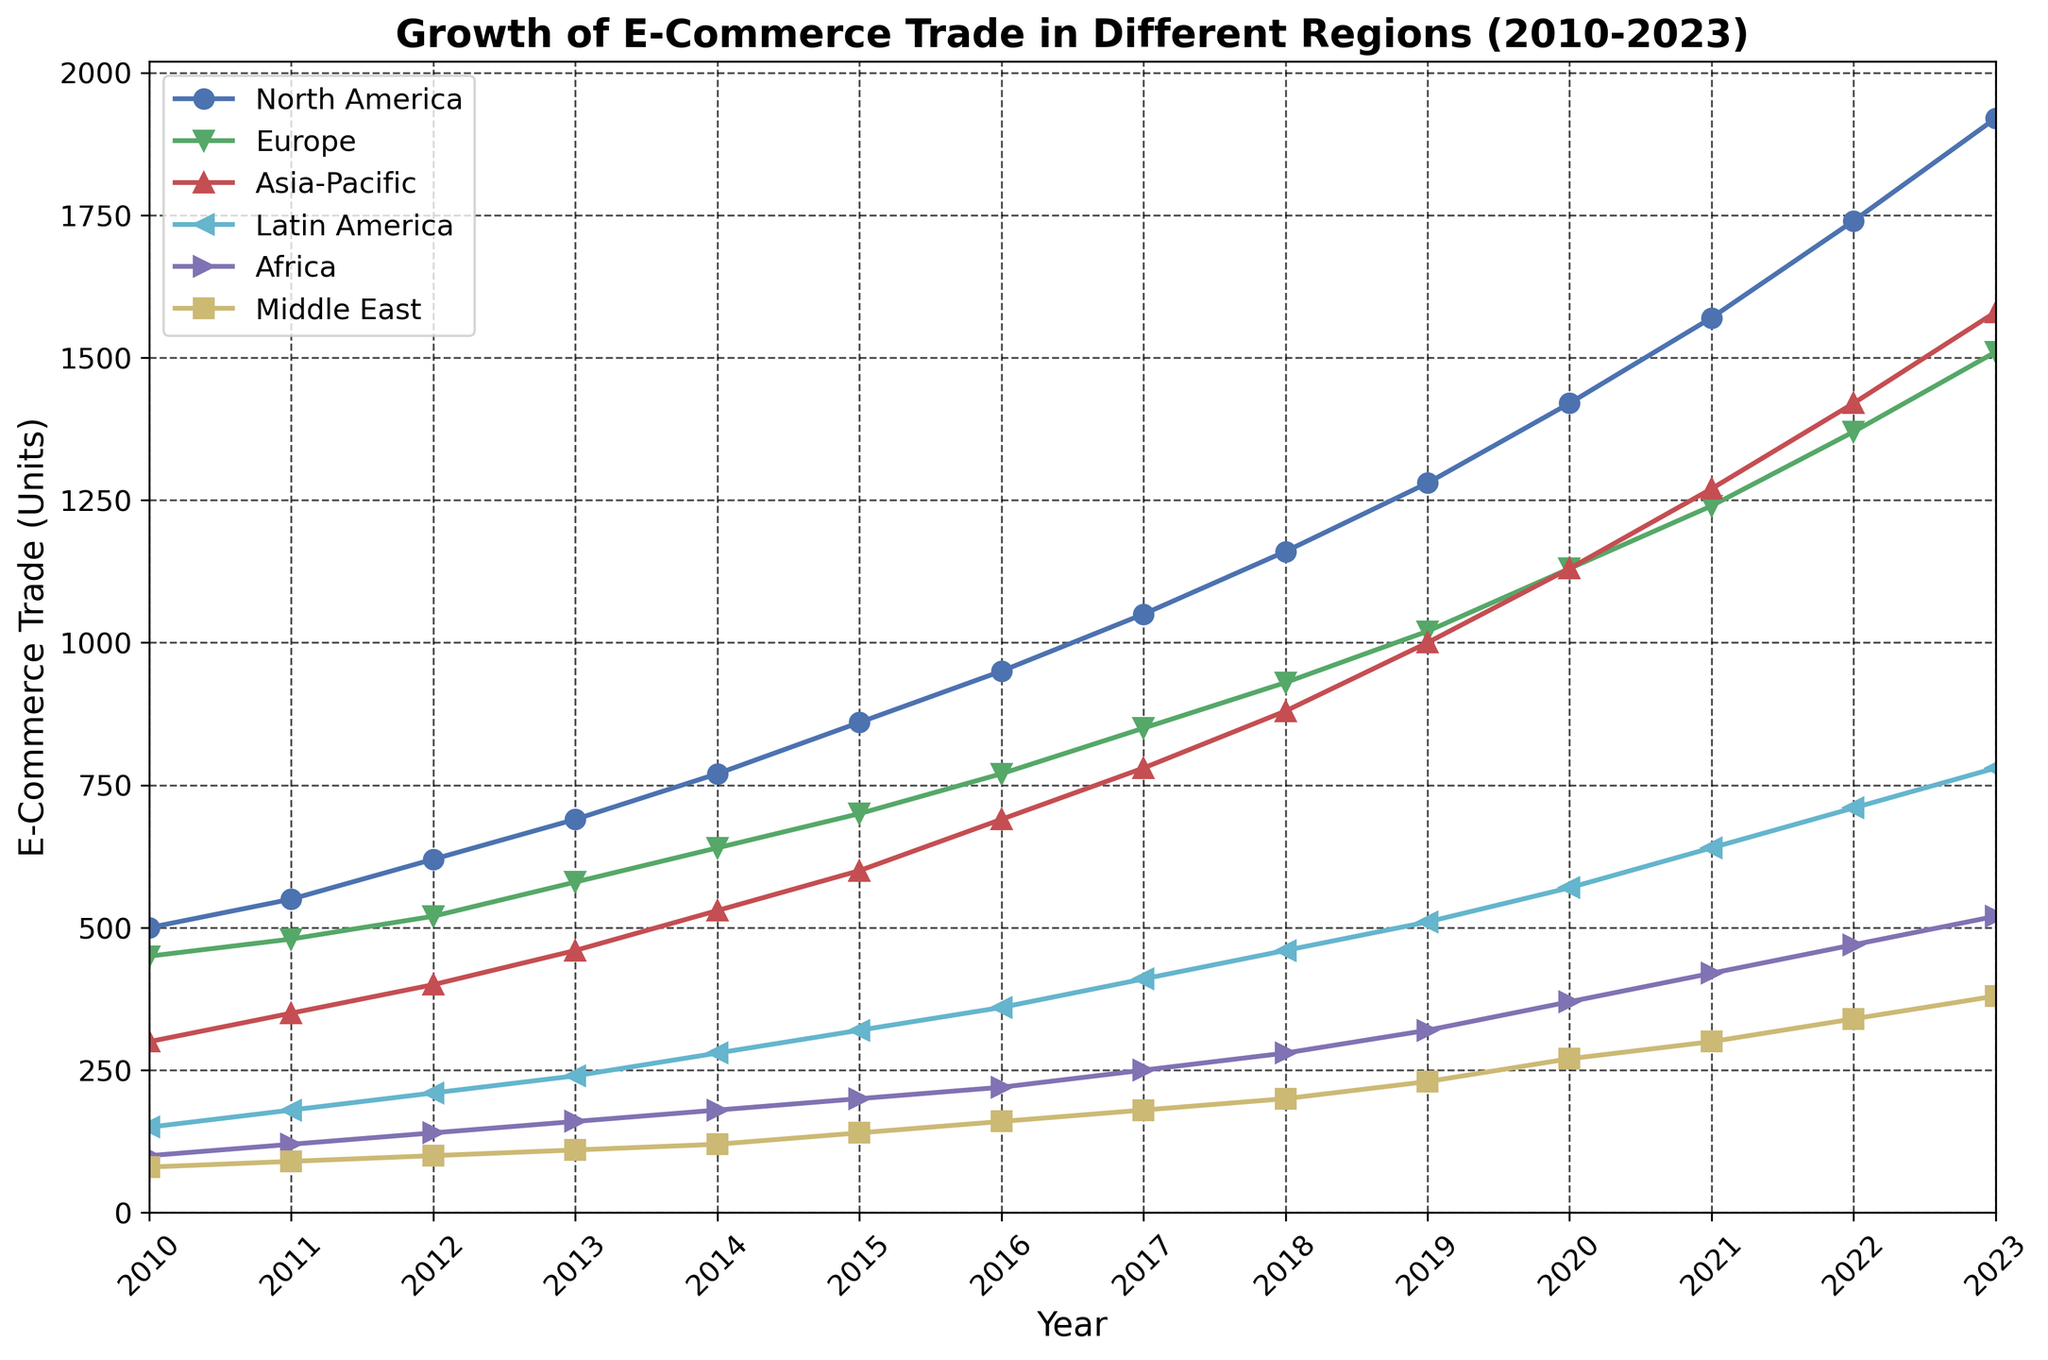What are the two regions with the highest e-commerce trade in 2023? First, notice the y-values for each region in 2023. The two highest are marked by the topmost lines. North America has 1920 units and Asia-Pacific has 1580 units.
Answer: North America and Asia-Pacific Which region had the largest growth in e-commerce trade from 2010 to 2023? To find the largest growth, calculate the difference between the values in 2023 and 2010 for each region. North America went from 500 to 1920, a growth of 1420 units, which is the largest.
Answer: North America How did the e-commerce trade in Europe in 2023 compare to 2020? Identify the y-values for Europe in 2023 and 2020. In 2020, Europe had 1130 units and in 2023, it had 1510 units. The increase is 1510 - 1130 = 380 units.
Answer: Increased by 380 units What was the average e-commerce trade in Asia-Pacific between 2010 and 2023? Add the values from 2010 to 2023 for Asia-Pacific and divide by the number of years. The sum is 300+350+400+460+530+600+690+780+880+1000+1130+1270+1420+1580 = 12390. There are 14 years, so 12390 / 14 = 885 units.
Answer: 885 units Compare the e-commerce trade of Latin America and Middle East in 2015. Which one was higher and by how much? Find the values for Latin America and Middle East in 2015. Latin America had 320 units and Middle East had 140 units. The difference is 320 - 140 = 180 units, with Latin America being higher.
Answer: Latin America by 180 units What is the trend of e-commerce trade in Africa from 2010 to 2023? Look at the line associated with Africa from 2010 to 2023. The line shows a steady increase from 100 units in 2010 to 520 units in 2023. This indicates a consistent upward trend.
Answer: Steady increase In which year did North America surpass 1000 units in e-commerce trade? Find the year where North America's value first exceeds 1000 units. This occurs in 2017, where it reaches 1050 units.
Answer: 2017 What is the difference in e-commerce trade between North America and Latin America in 2022? Identify the values for North America and Latin America in 2022. North America has 1740 units, and Latin America has 710 units. The difference is 1740 - 710 = 1030 units.
Answer: 1030 units Which region had the smallest growth rate in e-commerce trade from 2010 to 2023? Calculate the growth for each region from 2010 to 2023. The Middle East goes from 80 to 380, a growth of 300 units, which is the smallest among the regions.
Answer: Middle East 